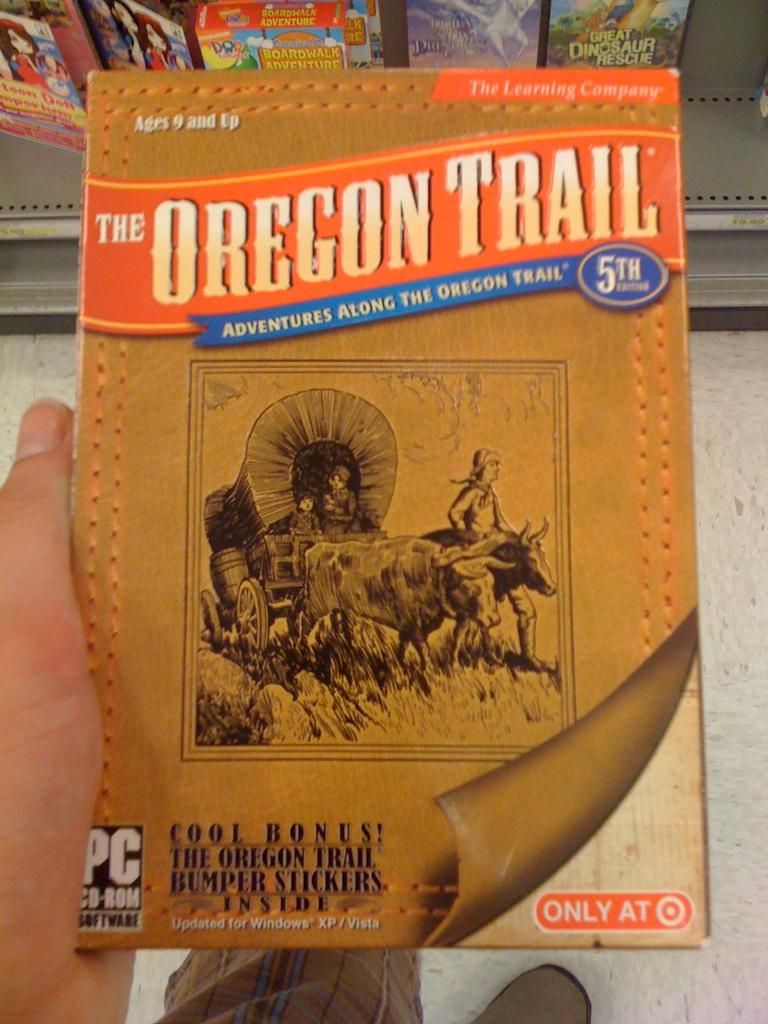<image>
Share a concise interpretation of the image provided. A PC CD-Rom that is titled "The Oregon Trail". 